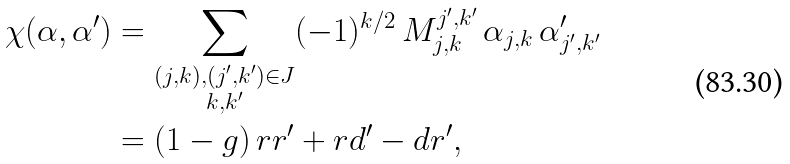<formula> <loc_0><loc_0><loc_500><loc_500>\chi ( \alpha , \alpha ^ { \prime } ) & = \sum _ { \substack { ( j , k ) , ( j ^ { \prime } , k ^ { \prime } ) \in J \\ k , k ^ { \prime } } } ( - 1 ) ^ { k / 2 } \, M _ { j , k } ^ { j ^ { \prime } , k ^ { \prime } } \, \alpha _ { j , k } \, \alpha ^ { \prime } _ { j ^ { \prime } , k ^ { \prime } } \\ & = ( 1 - g ) \, r r ^ { \prime } + r d ^ { \prime } - d r ^ { \prime } ,</formula> 